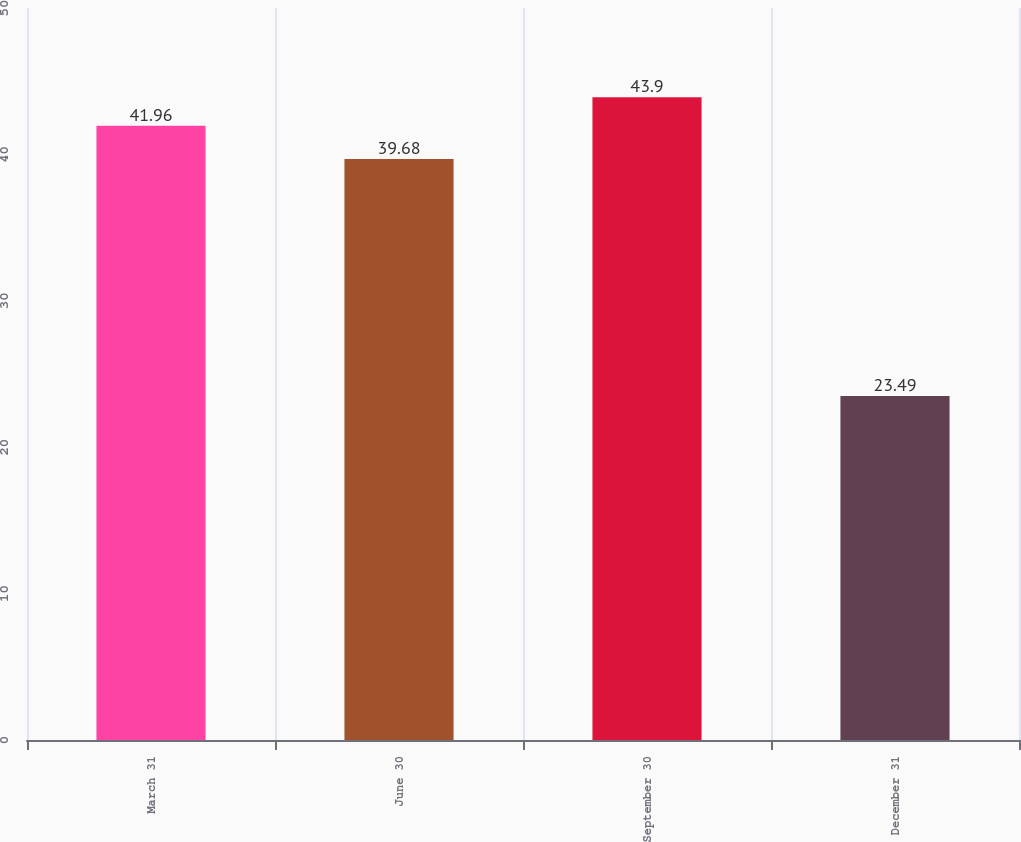Convert chart. <chart><loc_0><loc_0><loc_500><loc_500><bar_chart><fcel>March 31<fcel>June 30<fcel>September 30<fcel>December 31<nl><fcel>41.96<fcel>39.68<fcel>43.9<fcel>23.49<nl></chart> 